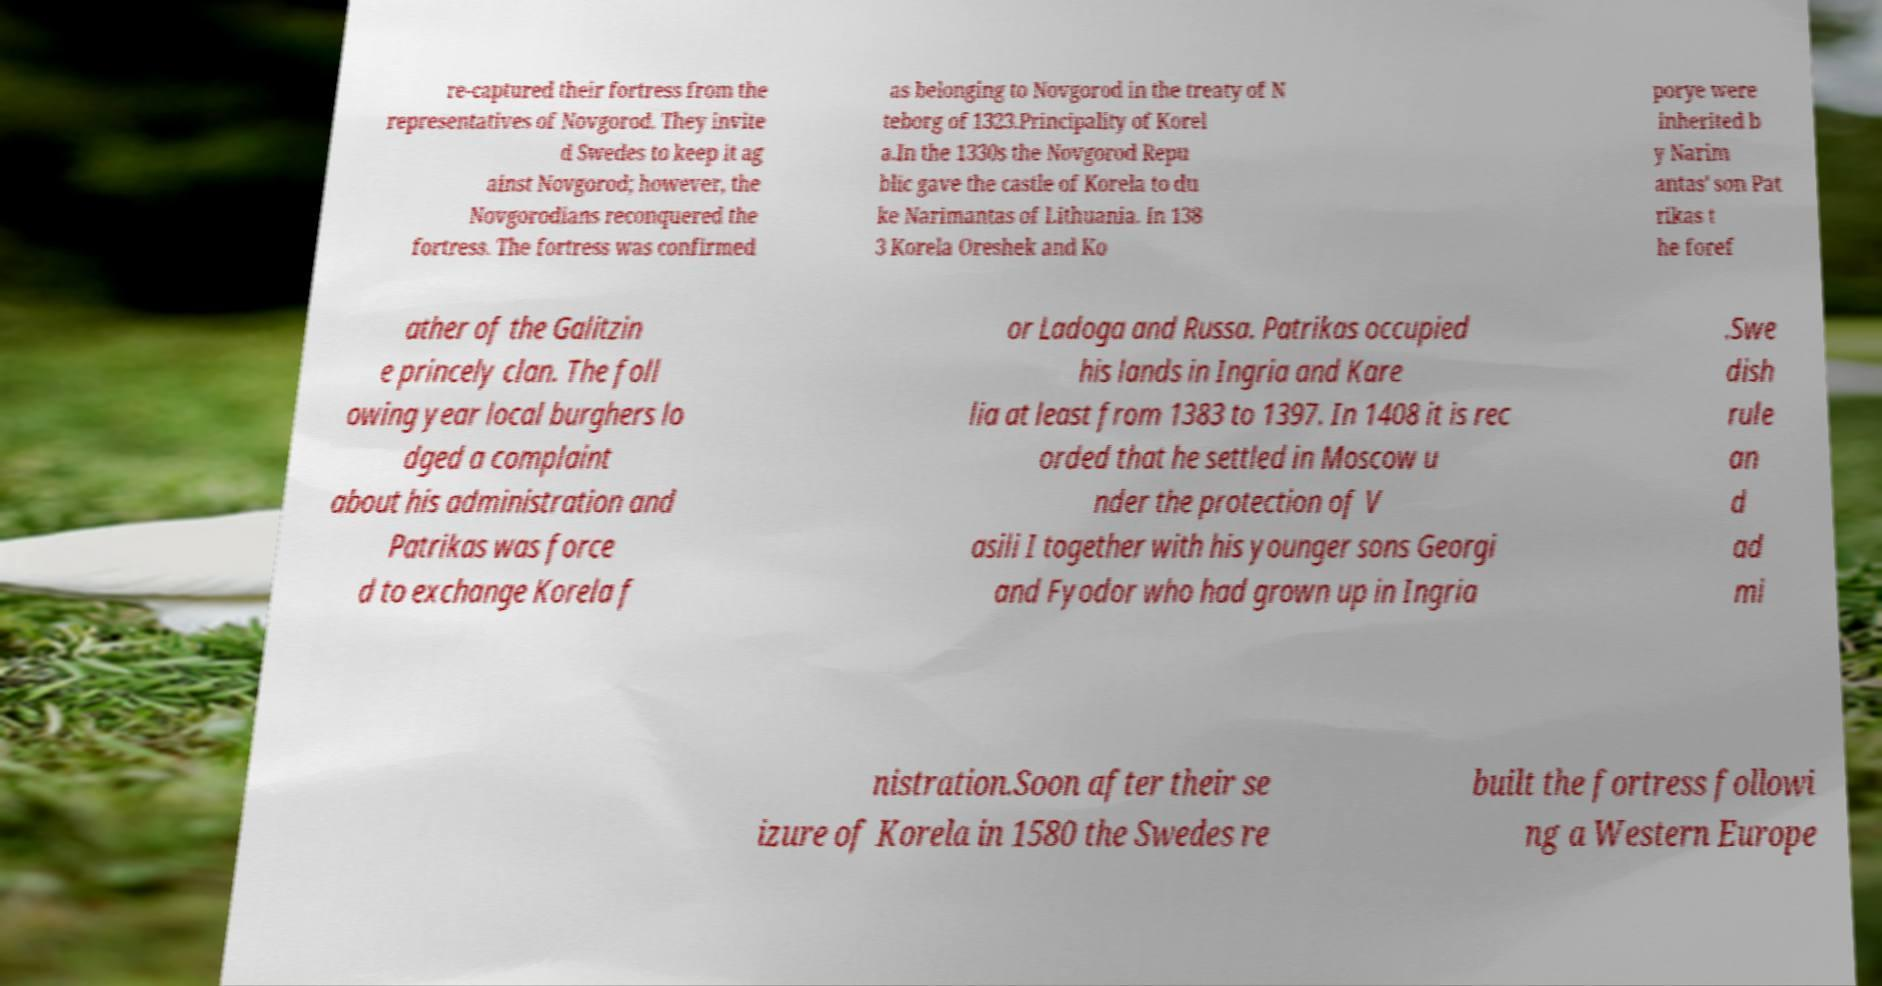Could you extract and type out the text from this image? re-captured their fortress from the representatives of Novgorod. They invite d Swedes to keep it ag ainst Novgorod; however, the Novgorodians reconquered the fortress. The fortress was confirmed as belonging to Novgorod in the treaty of N teborg of 1323.Principality of Korel a.In the 1330s the Novgorod Repu blic gave the castle of Korela to du ke Narimantas of Lithuania. In 138 3 Korela Oreshek and Ko porye were inherited b y Narim antas' son Pat rikas t he foref ather of the Galitzin e princely clan. The foll owing year local burghers lo dged a complaint about his administration and Patrikas was force d to exchange Korela f or Ladoga and Russa. Patrikas occupied his lands in Ingria and Kare lia at least from 1383 to 1397. In 1408 it is rec orded that he settled in Moscow u nder the protection of V asili I together with his younger sons Georgi and Fyodor who had grown up in Ingria .Swe dish rule an d ad mi nistration.Soon after their se izure of Korela in 1580 the Swedes re built the fortress followi ng a Western Europe 